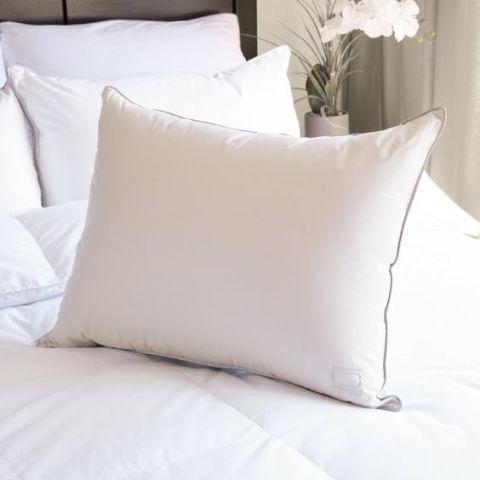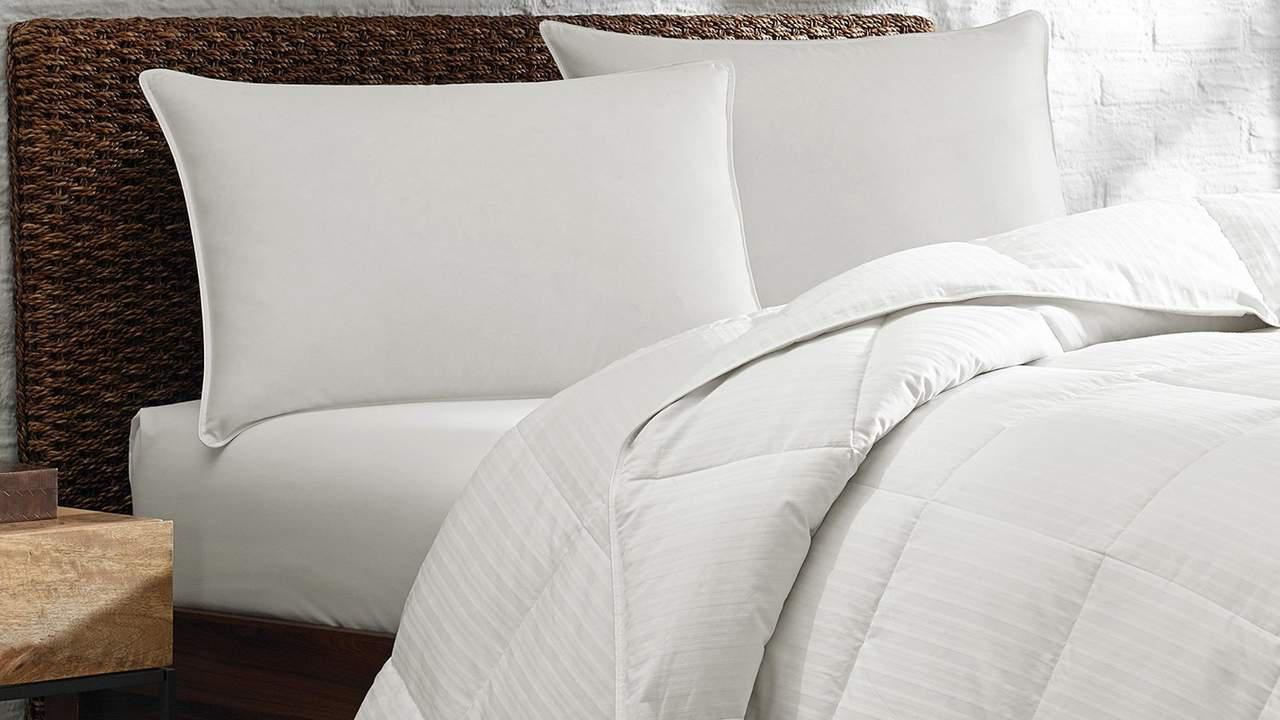The first image is the image on the left, the second image is the image on the right. Given the left and right images, does the statement "There is a vase of flowers in the image on the left." hold true? Answer yes or no. Yes. The first image is the image on the left, the second image is the image on the right. For the images displayed, is the sentence "There is a lamp visible in at least one image." factually correct? Answer yes or no. No. 